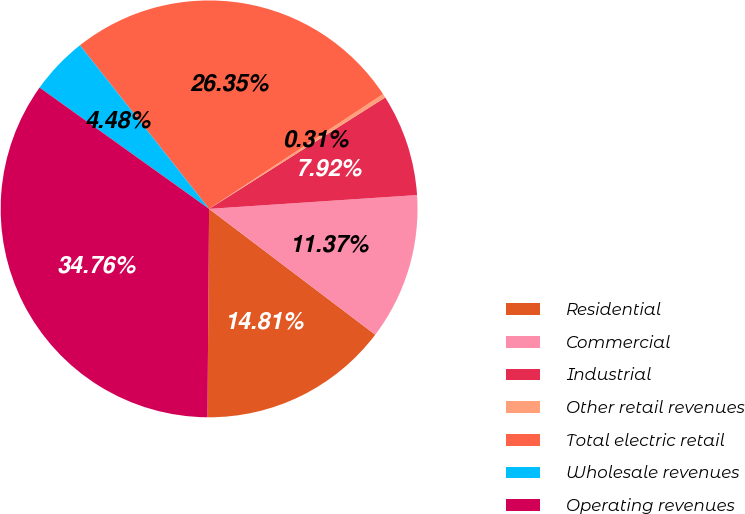<chart> <loc_0><loc_0><loc_500><loc_500><pie_chart><fcel>Residential<fcel>Commercial<fcel>Industrial<fcel>Other retail revenues<fcel>Total electric retail<fcel>Wholesale revenues<fcel>Operating revenues<nl><fcel>14.81%<fcel>11.37%<fcel>7.92%<fcel>0.31%<fcel>26.35%<fcel>4.48%<fcel>34.76%<nl></chart> 